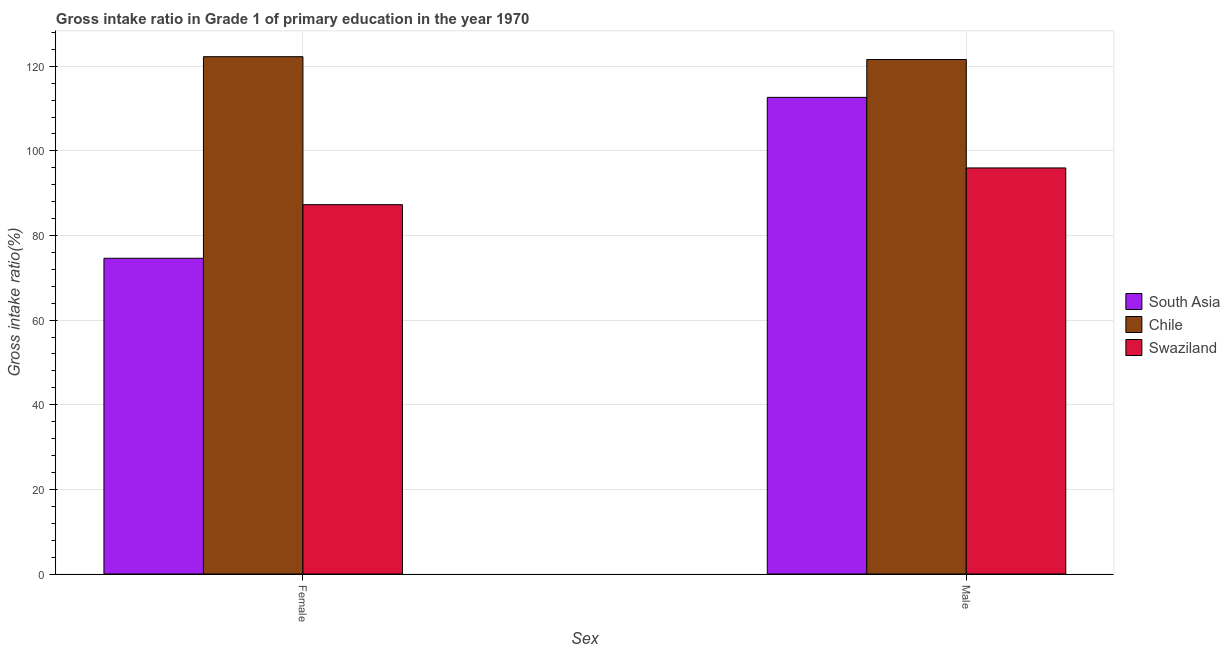Are the number of bars per tick equal to the number of legend labels?
Your response must be concise. Yes. Are the number of bars on each tick of the X-axis equal?
Your answer should be compact. Yes. What is the gross intake ratio(female) in Chile?
Provide a succinct answer. 122.25. Across all countries, what is the maximum gross intake ratio(female)?
Provide a short and direct response. 122.25. Across all countries, what is the minimum gross intake ratio(female)?
Your response must be concise. 74.61. In which country was the gross intake ratio(female) maximum?
Keep it short and to the point. Chile. In which country was the gross intake ratio(male) minimum?
Keep it short and to the point. Swaziland. What is the total gross intake ratio(female) in the graph?
Keep it short and to the point. 284.15. What is the difference between the gross intake ratio(female) in Swaziland and that in Chile?
Provide a short and direct response. -34.97. What is the difference between the gross intake ratio(female) in South Asia and the gross intake ratio(male) in Swaziland?
Offer a very short reply. -21.35. What is the average gross intake ratio(male) per country?
Provide a succinct answer. 110.06. What is the difference between the gross intake ratio(male) and gross intake ratio(female) in South Asia?
Provide a short and direct response. 38.03. In how many countries, is the gross intake ratio(female) greater than 44 %?
Provide a succinct answer. 3. What is the ratio of the gross intake ratio(male) in Chile to that in Swaziland?
Offer a very short reply. 1.27. What does the 1st bar from the right in Male represents?
Your answer should be very brief. Swaziland. How many bars are there?
Offer a very short reply. 6. How many countries are there in the graph?
Your answer should be very brief. 3. Are the values on the major ticks of Y-axis written in scientific E-notation?
Ensure brevity in your answer.  No. Does the graph contain any zero values?
Ensure brevity in your answer.  No. Where does the legend appear in the graph?
Offer a terse response. Center right. What is the title of the graph?
Give a very brief answer. Gross intake ratio in Grade 1 of primary education in the year 1970. What is the label or title of the X-axis?
Provide a short and direct response. Sex. What is the label or title of the Y-axis?
Your answer should be very brief. Gross intake ratio(%). What is the Gross intake ratio(%) in South Asia in Female?
Provide a short and direct response. 74.61. What is the Gross intake ratio(%) in Chile in Female?
Your answer should be very brief. 122.25. What is the Gross intake ratio(%) in Swaziland in Female?
Your answer should be compact. 87.28. What is the Gross intake ratio(%) in South Asia in Male?
Provide a succinct answer. 112.64. What is the Gross intake ratio(%) of Chile in Male?
Give a very brief answer. 121.58. What is the Gross intake ratio(%) of Swaziland in Male?
Keep it short and to the point. 95.96. Across all Sex, what is the maximum Gross intake ratio(%) of South Asia?
Provide a short and direct response. 112.64. Across all Sex, what is the maximum Gross intake ratio(%) of Chile?
Make the answer very short. 122.25. Across all Sex, what is the maximum Gross intake ratio(%) in Swaziland?
Provide a short and direct response. 95.96. Across all Sex, what is the minimum Gross intake ratio(%) in South Asia?
Make the answer very short. 74.61. Across all Sex, what is the minimum Gross intake ratio(%) in Chile?
Keep it short and to the point. 121.58. Across all Sex, what is the minimum Gross intake ratio(%) of Swaziland?
Your answer should be very brief. 87.28. What is the total Gross intake ratio(%) of South Asia in the graph?
Keep it short and to the point. 187.25. What is the total Gross intake ratio(%) in Chile in the graph?
Ensure brevity in your answer.  243.84. What is the total Gross intake ratio(%) in Swaziland in the graph?
Give a very brief answer. 183.24. What is the difference between the Gross intake ratio(%) in South Asia in Female and that in Male?
Ensure brevity in your answer.  -38.03. What is the difference between the Gross intake ratio(%) in Chile in Female and that in Male?
Ensure brevity in your answer.  0.67. What is the difference between the Gross intake ratio(%) in Swaziland in Female and that in Male?
Your answer should be compact. -8.68. What is the difference between the Gross intake ratio(%) in South Asia in Female and the Gross intake ratio(%) in Chile in Male?
Offer a very short reply. -46.97. What is the difference between the Gross intake ratio(%) of South Asia in Female and the Gross intake ratio(%) of Swaziland in Male?
Your answer should be very brief. -21.35. What is the difference between the Gross intake ratio(%) in Chile in Female and the Gross intake ratio(%) in Swaziland in Male?
Offer a terse response. 26.29. What is the average Gross intake ratio(%) in South Asia per Sex?
Offer a terse response. 93.63. What is the average Gross intake ratio(%) of Chile per Sex?
Offer a terse response. 121.92. What is the average Gross intake ratio(%) of Swaziland per Sex?
Make the answer very short. 91.62. What is the difference between the Gross intake ratio(%) in South Asia and Gross intake ratio(%) in Chile in Female?
Provide a succinct answer. -47.64. What is the difference between the Gross intake ratio(%) of South Asia and Gross intake ratio(%) of Swaziland in Female?
Offer a terse response. -12.67. What is the difference between the Gross intake ratio(%) in Chile and Gross intake ratio(%) in Swaziland in Female?
Provide a short and direct response. 34.97. What is the difference between the Gross intake ratio(%) of South Asia and Gross intake ratio(%) of Chile in Male?
Keep it short and to the point. -8.94. What is the difference between the Gross intake ratio(%) of South Asia and Gross intake ratio(%) of Swaziland in Male?
Your answer should be compact. 16.68. What is the difference between the Gross intake ratio(%) of Chile and Gross intake ratio(%) of Swaziland in Male?
Your answer should be compact. 25.62. What is the ratio of the Gross intake ratio(%) in South Asia in Female to that in Male?
Your answer should be very brief. 0.66. What is the ratio of the Gross intake ratio(%) in Chile in Female to that in Male?
Provide a succinct answer. 1.01. What is the ratio of the Gross intake ratio(%) of Swaziland in Female to that in Male?
Give a very brief answer. 0.91. What is the difference between the highest and the second highest Gross intake ratio(%) in South Asia?
Provide a succinct answer. 38.03. What is the difference between the highest and the second highest Gross intake ratio(%) of Chile?
Ensure brevity in your answer.  0.67. What is the difference between the highest and the second highest Gross intake ratio(%) of Swaziland?
Make the answer very short. 8.68. What is the difference between the highest and the lowest Gross intake ratio(%) of South Asia?
Provide a short and direct response. 38.03. What is the difference between the highest and the lowest Gross intake ratio(%) in Chile?
Provide a short and direct response. 0.67. What is the difference between the highest and the lowest Gross intake ratio(%) in Swaziland?
Give a very brief answer. 8.68. 